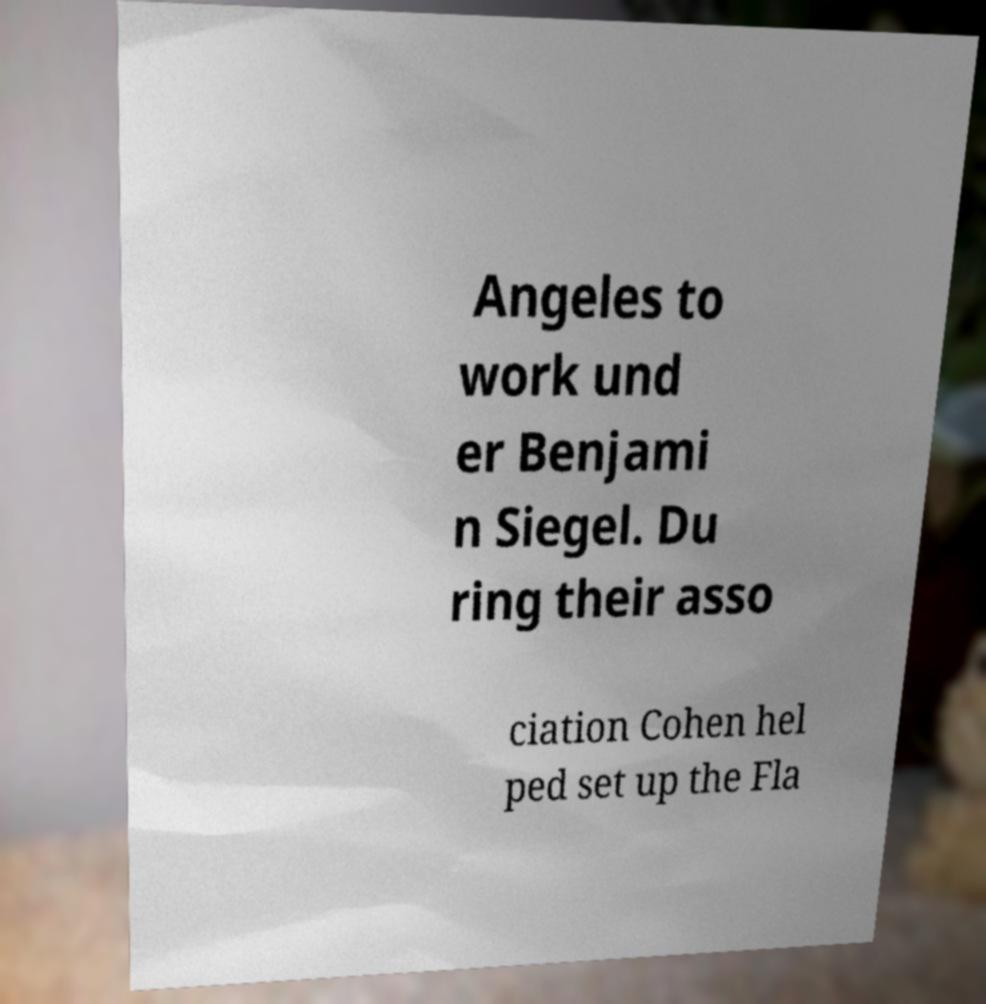There's text embedded in this image that I need extracted. Can you transcribe it verbatim? Angeles to work und er Benjami n Siegel. Du ring their asso ciation Cohen hel ped set up the Fla 